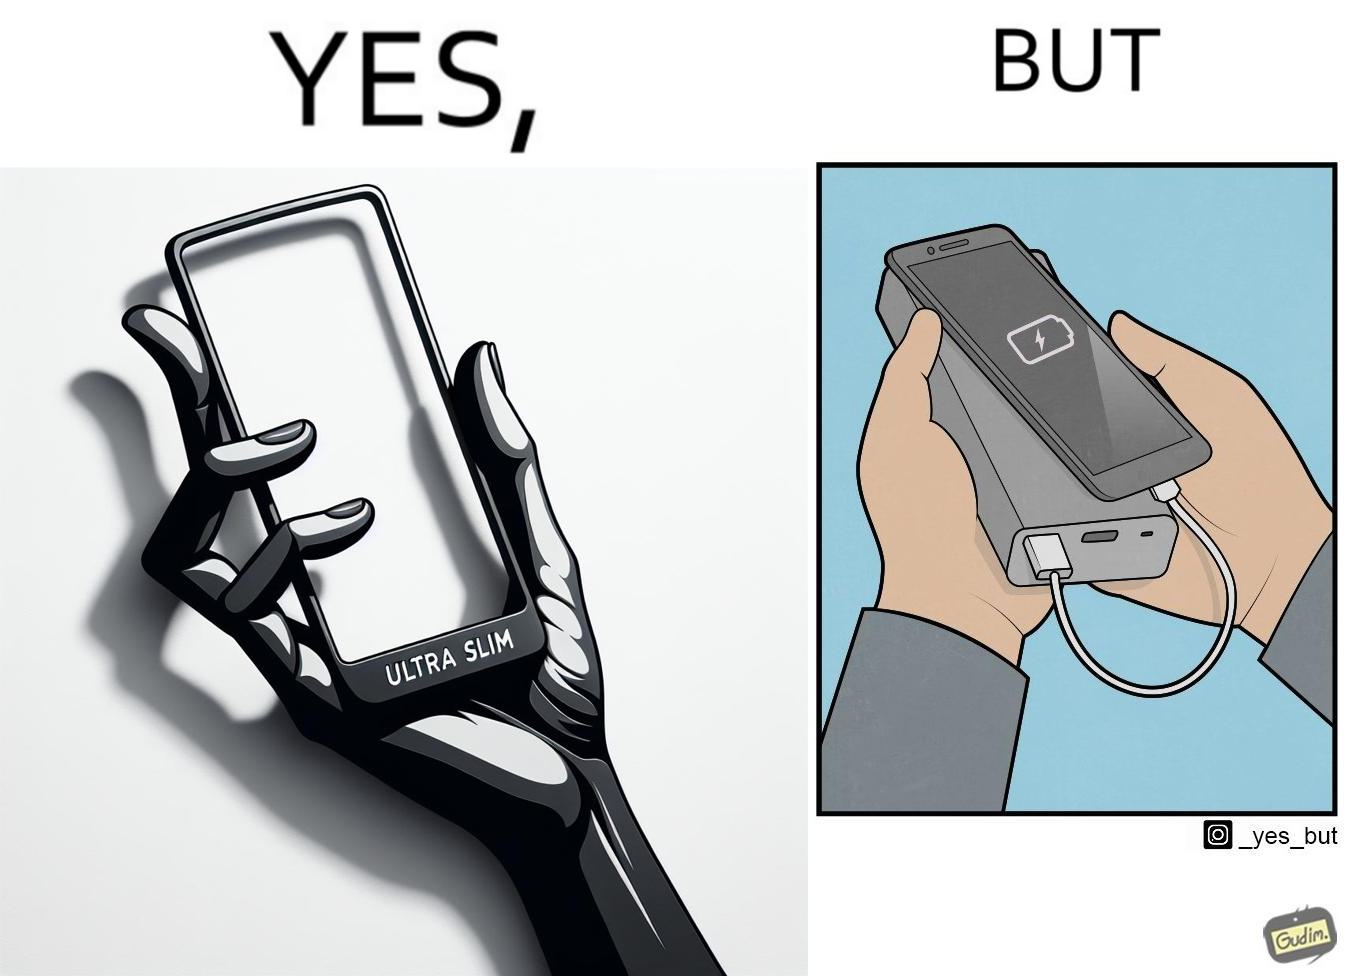Describe the content of this image. The image is satirical because even though the mobile phone has been developed to be very slim, it requires frequent recharging which makes the mobile phone useless without a big, heavy and thick power bank. 